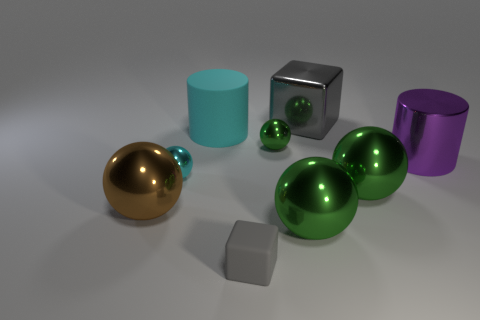Is there any other thing that is the same shape as the small rubber object?
Keep it short and to the point. Yes. There is a shiny object that is the same shape as the large matte object; what is its color?
Provide a short and direct response. Purple. There is a purple object to the right of the small green sphere; what material is it?
Offer a terse response. Metal. What color is the big block?
Provide a succinct answer. Gray. Is the size of the gray object that is in front of the shiny cube the same as the large gray block?
Keep it short and to the point. No. There is a block to the right of the gray thing to the left of the large metal object behind the cyan cylinder; what is it made of?
Make the answer very short. Metal. There is a big cylinder right of the cyan cylinder; does it have the same color as the large sphere behind the big brown metallic ball?
Give a very brief answer. No. What is the material of the gray thing that is right of the big ball that is in front of the brown ball?
Provide a succinct answer. Metal. What color is the rubber object that is the same size as the brown ball?
Provide a short and direct response. Cyan. Does the gray metal object have the same shape as the big shiny object to the left of the cyan matte cylinder?
Provide a short and direct response. No. 